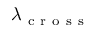<formula> <loc_0><loc_0><loc_500><loc_500>\lambda _ { c r o s s }</formula> 